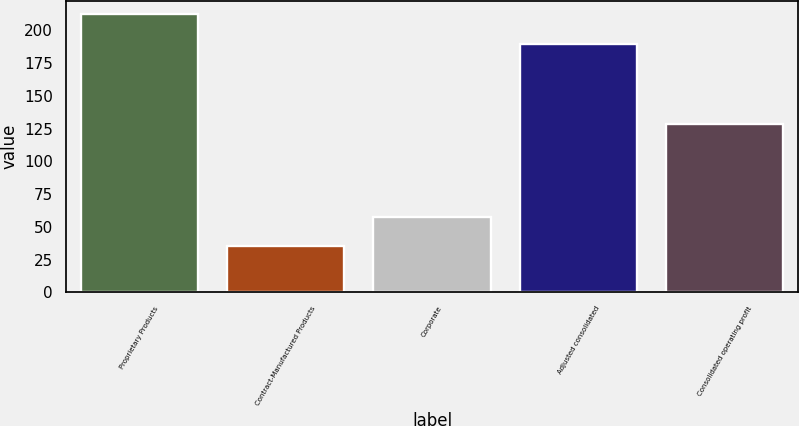Convert chart to OTSL. <chart><loc_0><loc_0><loc_500><loc_500><bar_chart><fcel>Proprietary Products<fcel>Contract-Manufactured Products<fcel>Corporate<fcel>Adjusted consolidated<fcel>Consolidated operating profit<nl><fcel>212.2<fcel>35.5<fcel>57.8<fcel>189.9<fcel>128.6<nl></chart> 